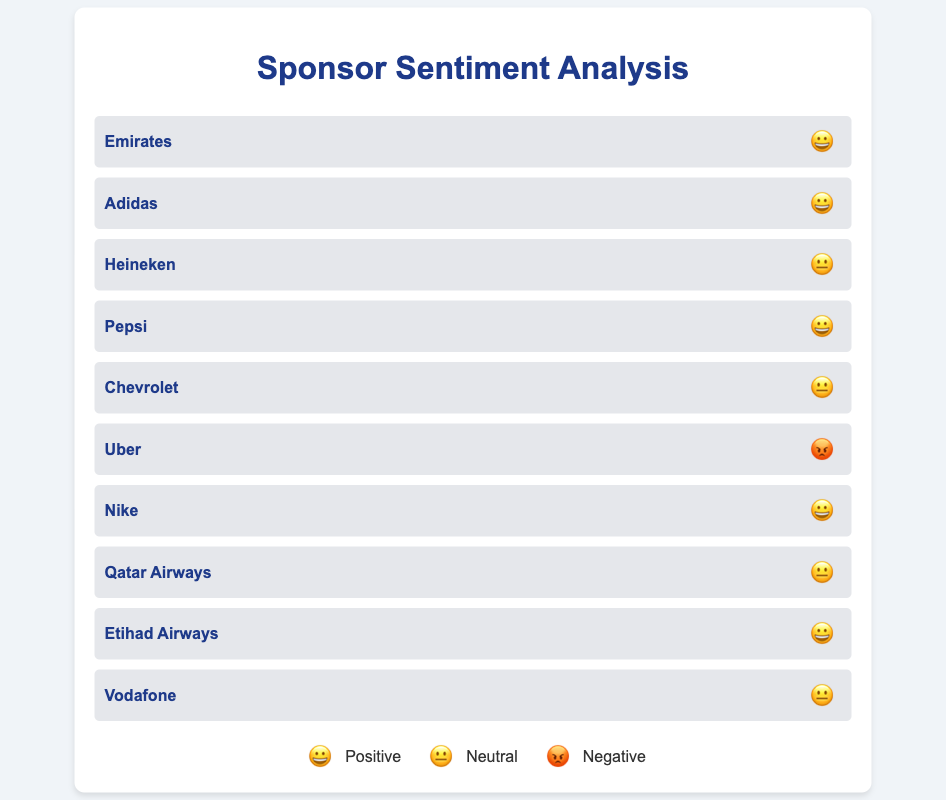What's the overall sentiment of Emirates? Emirates has a positive sentiment marked by a 😀 emoji.
Answer: Positive How many sponsors have a neutral sentiment? Count the sponsors marked with a 😐 emoji, which are Heineken, Chevrolet, Qatar Airways, and Vodafone. 4 sponsors have a neutral sentiment.
Answer: 4 Which sponsor has a negative sentiment? Look through the chart for the 😡 emoji, which represents negative sentiment. The sponsor is Uber.
Answer: Uber Compare the number of sponsors with positive and negative sentiment. Which is higher? The chart shows six sponsors with a positive sentiment (😀), and only one sponsor with a negative sentiment (😡). Positive sentiment is higher.
Answer: Positive sentiment How many sponsors have a positive sentiment? Count the sponsors marked with a 😀 emoji, which are Emirates, Adidas, Pepsi, Nike, Etihad Airways. 5 sponsors have a positive sentiment.
Answer: 5 What's the ratio of sponsors with neutral sentiment to those with positive sentiment? There are 4 sponsors with neutral sentiment and 5 sponsors with positive sentiment. The ratio is 4:5.
Answer: 4:5 Which sponsor represents the neutral sentiment in the airline industry? Among the sponsors with a neutral sentiment (😐), identify the one related to airlines, which is Qatar Airways.
Answer: Qatar Airways What's the difference in the number of sponsors with neutral sentiment compared to those with negative sentiment? Count the sponsors with neutral sentiment (4) and those with negative sentiment (1). The difference is 4 - 1 = 3.
Answer: 3 List all the sponsors with a positive sentiment. Identify all sponsors marked with a 😀 emoji. The sponsors are Emirates, Adidas, Pepsi, Nike, and Etihad Airways.
Answer: Emirates, Adidas, Pepsi, Nike, Etihad Airways How many airlines are represented in the chart and what's their collective sentiment? Identify the airlines: Emirates, Qatar Airways, and Etihad Airways. Emirates and Etihad Airways have a positive sentiment (😀), and Qatar Airways has a neutral sentiment (😐).
Answer: Three airlines; two positive and one neutral 